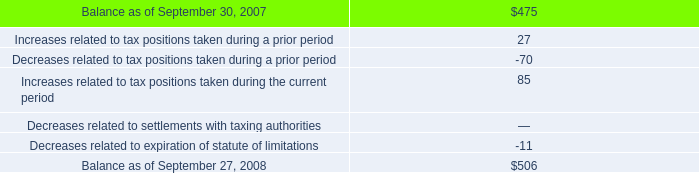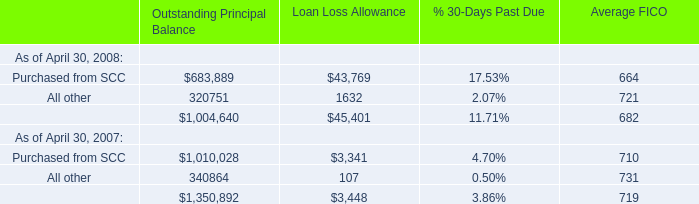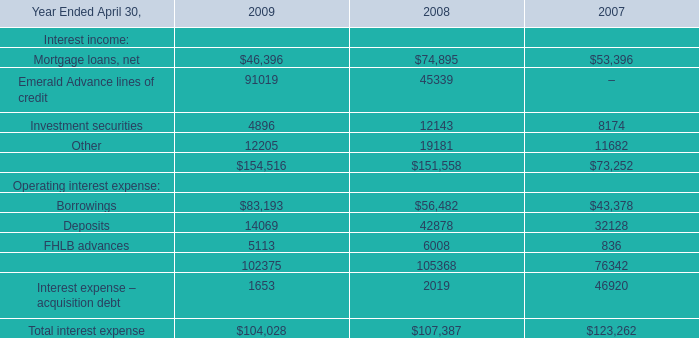In the year with largest amount of Purchased from SCC of Loan Loss Allowance in Table 1, what's the increasing rate of Investment securities in Table 2? 
Computations: ((12143 - 8174) / 8174)
Answer: 0.48556. 